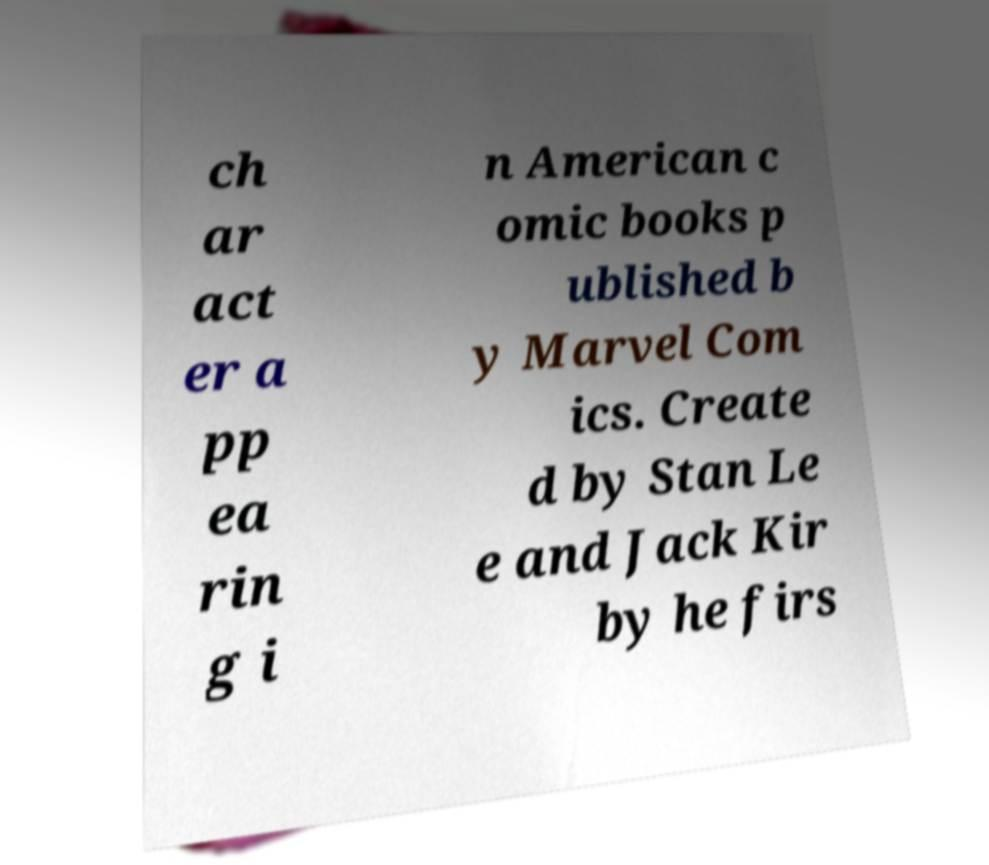For documentation purposes, I need the text within this image transcribed. Could you provide that? ch ar act er a pp ea rin g i n American c omic books p ublished b y Marvel Com ics. Create d by Stan Le e and Jack Kir by he firs 